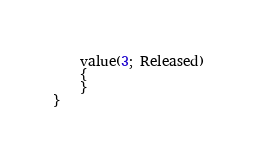<code> <loc_0><loc_0><loc_500><loc_500><_Perl_>    value(3; Released)
    {
    }
}</code> 